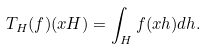<formula> <loc_0><loc_0><loc_500><loc_500>T _ { H } ( f ) ( x H ) = \int _ { H } f ( x h ) d h .</formula> 